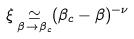Convert formula to latex. <formula><loc_0><loc_0><loc_500><loc_500>\xi \mathop \simeq _ { \beta \to \beta _ { c } } ( \beta _ { c } - \beta ) ^ { - \nu }</formula> 